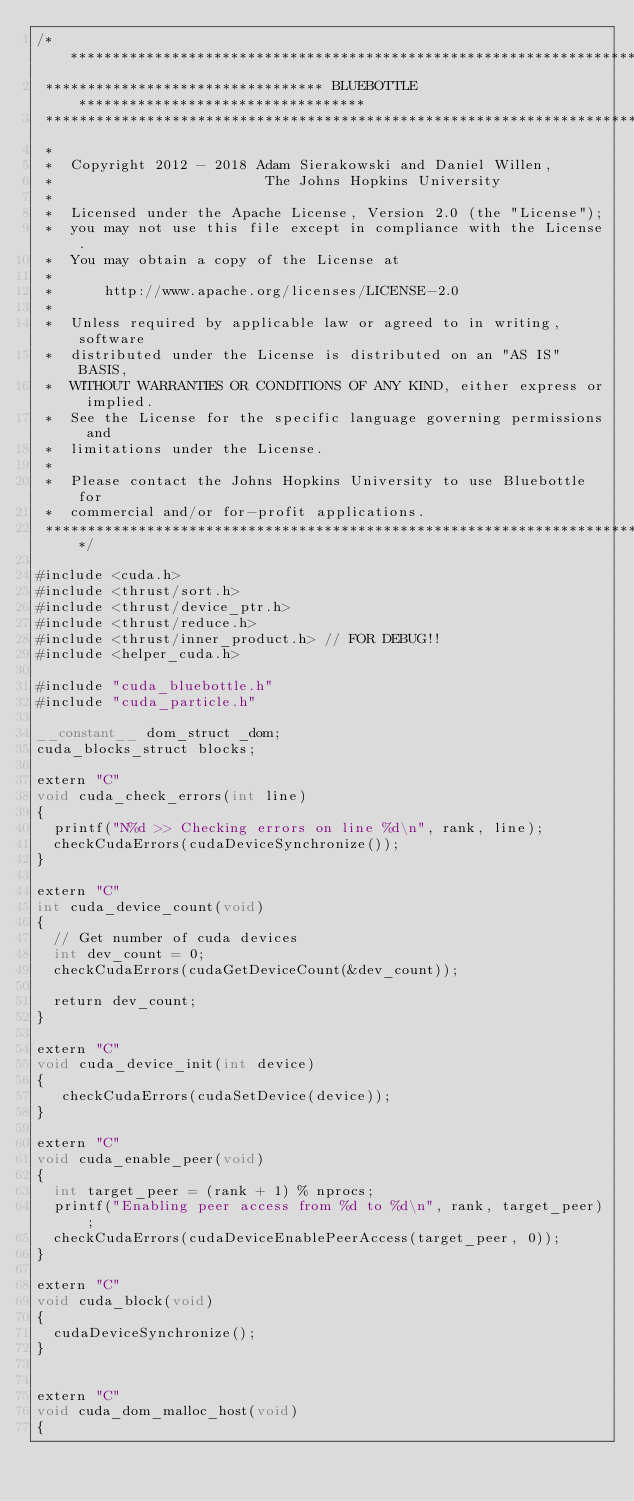<code> <loc_0><loc_0><loc_500><loc_500><_Cuda_>/*******************************************************************************
 ********************************* BLUEBOTTLE **********************************
 *******************************************************************************
 *
 *  Copyright 2012 - 2018 Adam Sierakowski and Daniel Willen, 
 *                         The Johns Hopkins University
 *
 *  Licensed under the Apache License, Version 2.0 (the "License");
 *  you may not use this file except in compliance with the License.
 *  You may obtain a copy of the License at
 *
 *      http://www.apache.org/licenses/LICENSE-2.0
 *
 *  Unless required by applicable law or agreed to in writing, software
 *  distributed under the License is distributed on an "AS IS" BASIS,
 *  WITHOUT WARRANTIES OR CONDITIONS OF ANY KIND, either express or implied.
 *  See the License for the specific language governing permissions and
 *  limitations under the License.
 *
 *  Please contact the Johns Hopkins University to use Bluebottle for
 *  commercial and/or for-profit applications.
 ******************************************************************************/

#include <cuda.h>
#include <thrust/sort.h>
#include <thrust/device_ptr.h>
#include <thrust/reduce.h>
#include <thrust/inner_product.h> // FOR DEBUG!!
#include <helper_cuda.h>

#include "cuda_bluebottle.h"
#include "cuda_particle.h"

__constant__ dom_struct _dom;
cuda_blocks_struct blocks;

extern "C"
void cuda_check_errors(int line)
{
  printf("N%d >> Checking errors on line %d\n", rank, line);
  checkCudaErrors(cudaDeviceSynchronize());
}

extern "C"
int cuda_device_count(void)
{
  // Get number of cuda devices
  int dev_count = 0;
  checkCudaErrors(cudaGetDeviceCount(&dev_count));

  return dev_count;
}

extern "C"
void cuda_device_init(int device)
{
   checkCudaErrors(cudaSetDevice(device));
}

extern "C"
void cuda_enable_peer(void)
{
  int target_peer = (rank + 1) % nprocs;
  printf("Enabling peer access from %d to %d\n", rank, target_peer);
  checkCudaErrors(cudaDeviceEnablePeerAccess(target_peer, 0));
}

extern "C"
void cuda_block(void)
{
  cudaDeviceSynchronize();
}


extern "C"
void cuda_dom_malloc_host(void)
{</code> 